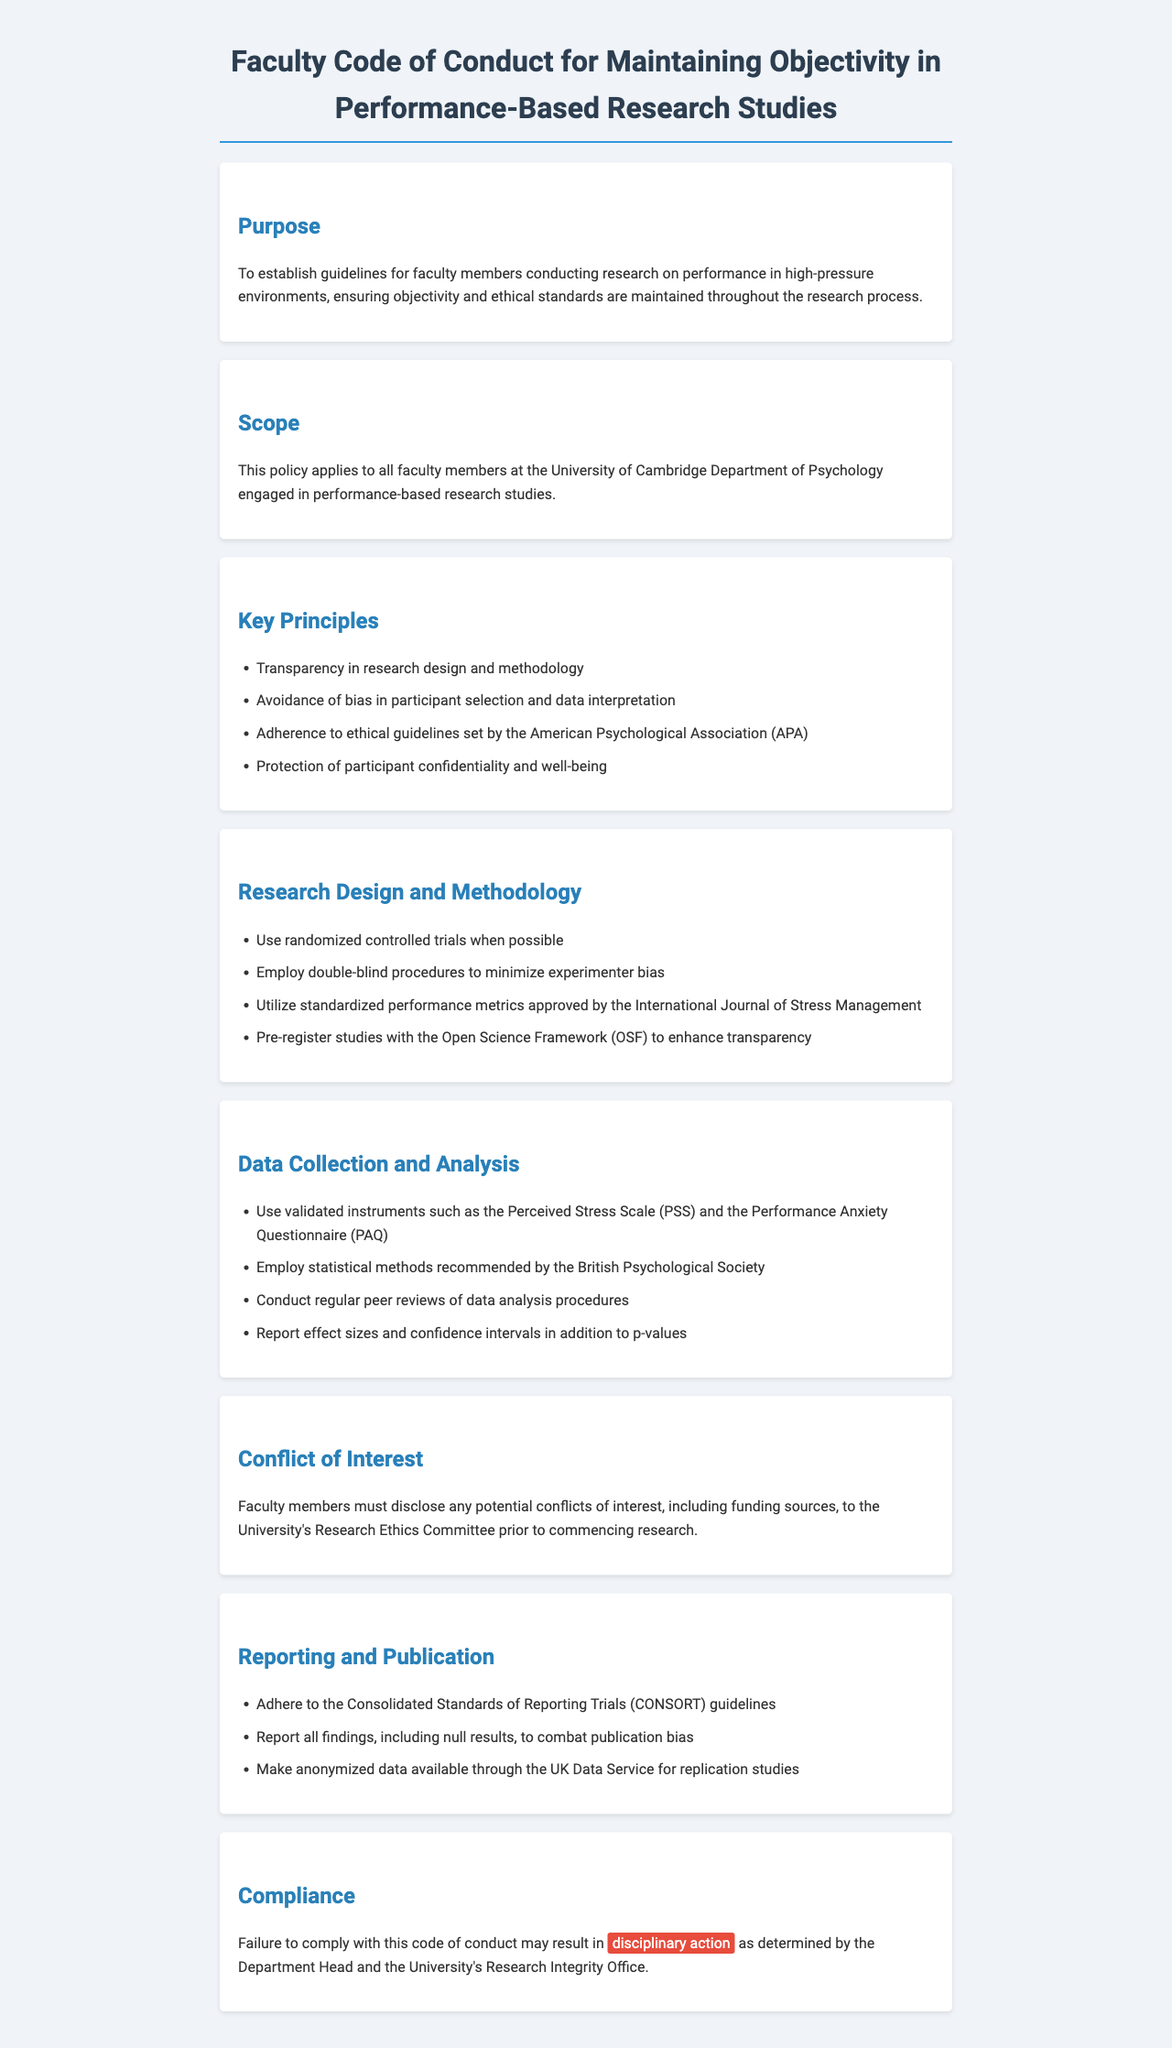What is the purpose of the policy? The purpose is to establish guidelines for faculty members conducting research on performance in high-pressure environments, ensuring objectivity and ethical standards are maintained throughout the research process.
Answer: Establish guidelines for faculty members conducting research on performance in high-pressure environments Who does the policy apply to? The policy applies to all faculty members at the University of Cambridge Department of Psychology engaged in performance-based research studies.
Answer: Faculty members at the University of Cambridge Department of Psychology What is one key principle mentioned in the document? One key principle is avoidance of bias in participant selection and data interpretation.
Answer: Avoidance of bias in participant selection and data interpretation What type of trials should be used when possible? The document recommends using randomized controlled trials when possible to enhance research objectivity.
Answer: Randomized controlled trials What should faculty members disclose according to the Conflict of Interest section? Faculty members must disclose any potential conflicts of interest, including funding sources, to the University's Research Ethics Committee.
Answer: Potential conflicts of interest, including funding sources What guidelines should be adhered to in reporting and publication? The guidelines recommended are the Consolidated Standards of Reporting Trials (CONSORT) guidelines.
Answer: Consolidated Standards of Reporting Trials (CONSORT) guidelines What happens if there is non-compliance with the code of conduct? Failure to comply with this code of conduct may result in disciplinary action as determined by the Department Head and the University's Research Integrity Office.
Answer: Disciplinary action What instruments should be used for data collection? Validated instruments such as the Perceived Stress Scale (PSS) and the Performance Anxiety Questionnaire (PAQ) should be used.
Answer: Perceived Stress Scale (PSS) and Performance Anxiety Questionnaire (PAQ) Which framework should researchers pre-register their studies with? Researchers should pre-register studies with the Open Science Framework (OSF) to enhance transparency.
Answer: Open Science Framework (OSF) 